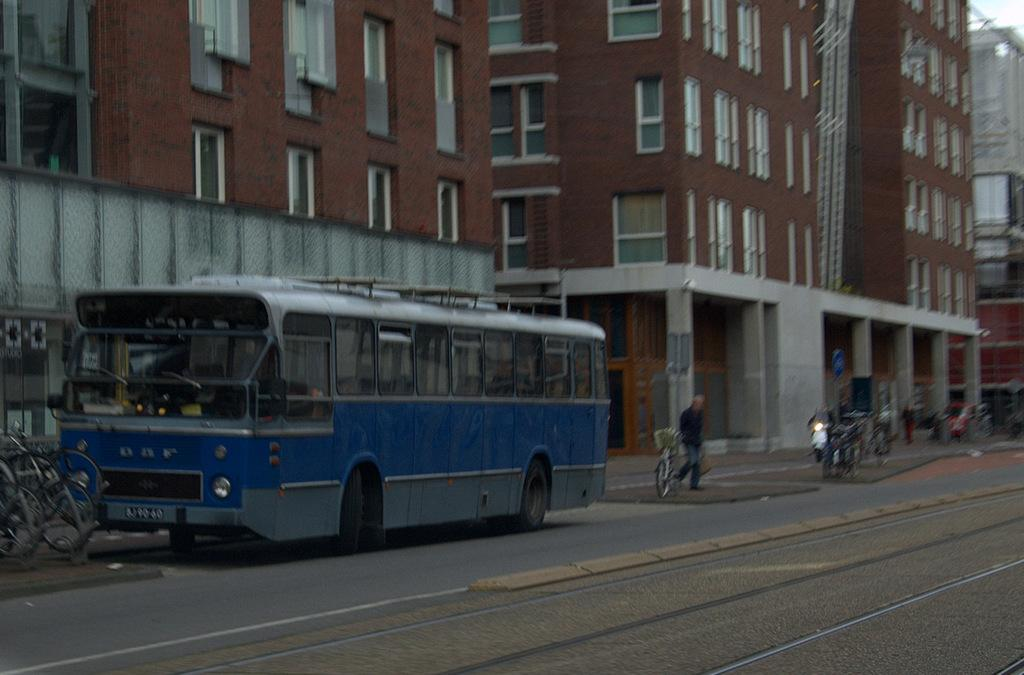What can be seen on the road in the foreground of the image? There is a track and vehicles on the road in the foreground of the image. What type of structures are visible in the background of the image? There are buildings in the background of the image. What is visible in the sky in the background of the image? The sky is visible in the background of the image. Are there any icicles hanging from the buildings in the image? There is no mention of icicles in the provided facts, and therefore we cannot determine if any are present in the image. What type of food is being served in the vehicles in the image? There is no indication of food being served in the vehicles in the image. 